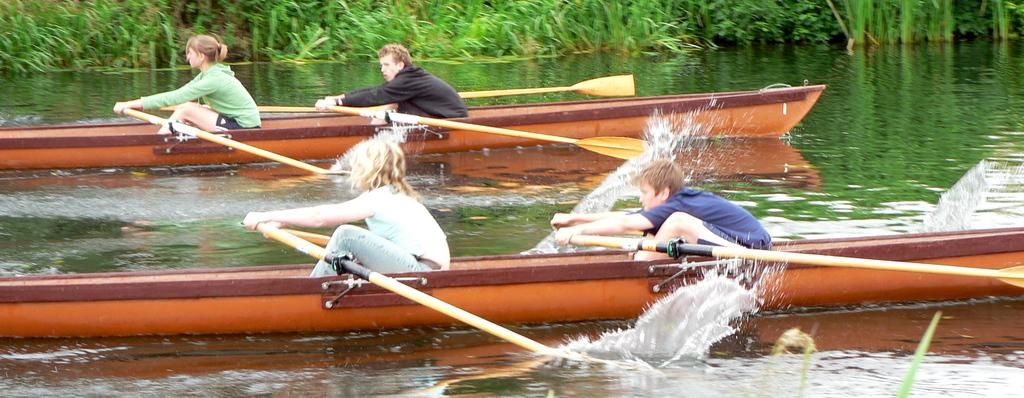What can be seen in the image related to water transportation? There are two boats in the image. How many people are on each boat? Each boat has two people on it. What are the people doing on the boats? The people are sailing the boats. What can be seen in the background of the image? There are plants visible in the background of the image. What type of foot can be seen on the boat in the image? There are no feet visible on the boats in the image; only the people's bodies and the boats themselves are present. 